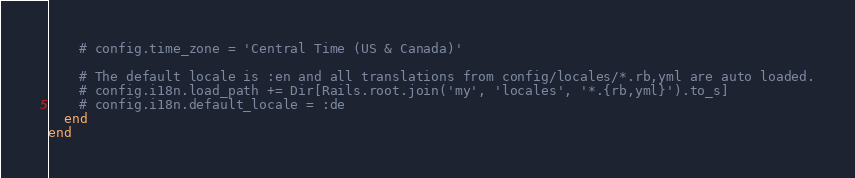Convert code to text. <code><loc_0><loc_0><loc_500><loc_500><_Ruby_>    # config.time_zone = 'Central Time (US & Canada)'

    # The default locale is :en and all translations from config/locales/*.rb,yml are auto loaded.
    # config.i18n.load_path += Dir[Rails.root.join('my', 'locales', '*.{rb,yml}').to_s]
    # config.i18n.default_locale = :de
  end
end

</code> 